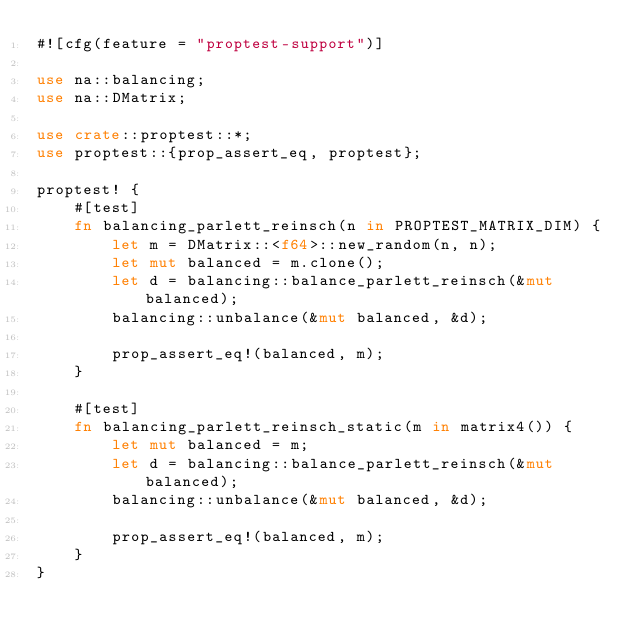Convert code to text. <code><loc_0><loc_0><loc_500><loc_500><_Rust_>#![cfg(feature = "proptest-support")]

use na::balancing;
use na::DMatrix;

use crate::proptest::*;
use proptest::{prop_assert_eq, proptest};

proptest! {
    #[test]
    fn balancing_parlett_reinsch(n in PROPTEST_MATRIX_DIM) {
        let m = DMatrix::<f64>::new_random(n, n);
        let mut balanced = m.clone();
        let d = balancing::balance_parlett_reinsch(&mut balanced);
        balancing::unbalance(&mut balanced, &d);

        prop_assert_eq!(balanced, m);
    }

    #[test]
    fn balancing_parlett_reinsch_static(m in matrix4()) {
        let mut balanced = m;
        let d = balancing::balance_parlett_reinsch(&mut balanced);
        balancing::unbalance(&mut balanced, &d);

        prop_assert_eq!(balanced, m);
    }
}
</code> 